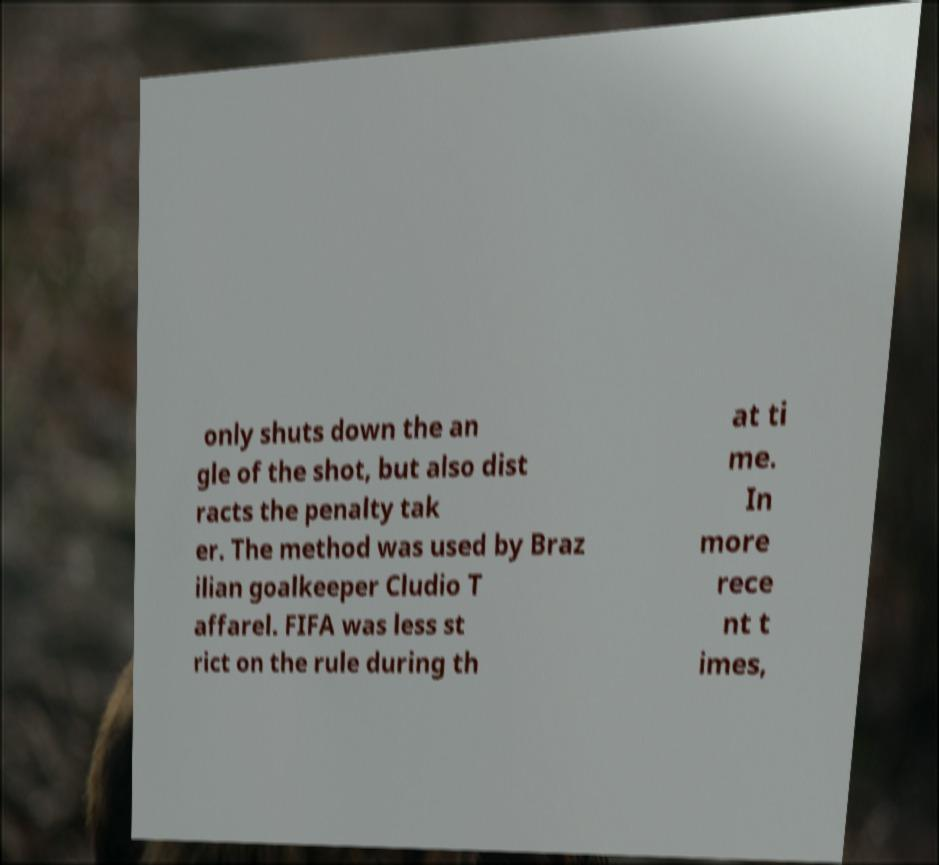Can you read and provide the text displayed in the image?This photo seems to have some interesting text. Can you extract and type it out for me? only shuts down the an gle of the shot, but also dist racts the penalty tak er. The method was used by Braz ilian goalkeeper Cludio T affarel. FIFA was less st rict on the rule during th at ti me. In more rece nt t imes, 